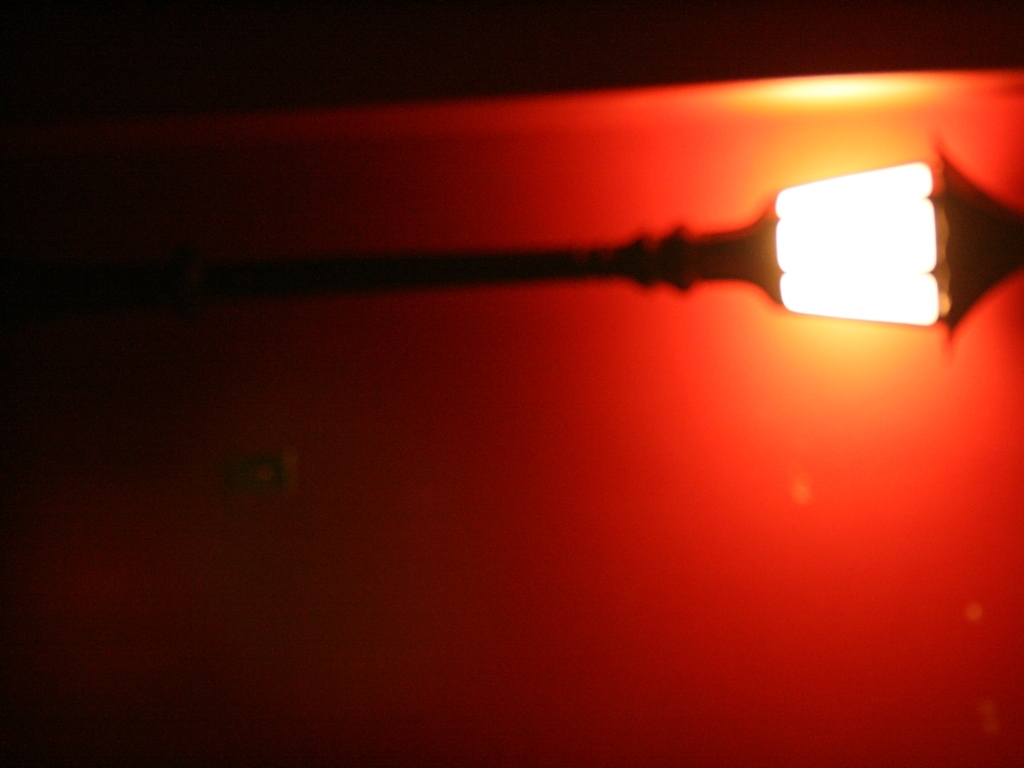How would you interpret the composition of this picture? The composition is minimalist, focusing on the juxtaposition of light and shadow. The placement of the light source towards the upper third of the frame implies an intention to draw the viewer's attention to the light, possibly suggesting a thematic emphasis on hope or discovery. 